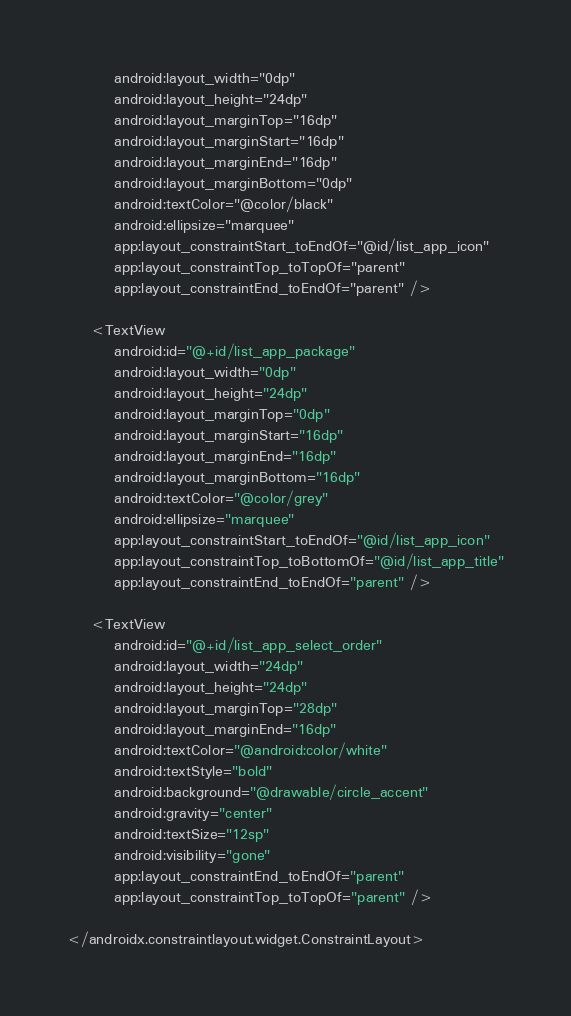Convert code to text. <code><loc_0><loc_0><loc_500><loc_500><_XML_>        android:layout_width="0dp"
        android:layout_height="24dp"
        android:layout_marginTop="16dp"
        android:layout_marginStart="16dp"
        android:layout_marginEnd="16dp"
        android:layout_marginBottom="0dp"
        android:textColor="@color/black"
        android:ellipsize="marquee"
        app:layout_constraintStart_toEndOf="@id/list_app_icon"
        app:layout_constraintTop_toTopOf="parent"
        app:layout_constraintEnd_toEndOf="parent" />

    <TextView
        android:id="@+id/list_app_package"
        android:layout_width="0dp"
        android:layout_height="24dp"
        android:layout_marginTop="0dp"
        android:layout_marginStart="16dp"
        android:layout_marginEnd="16dp"
        android:layout_marginBottom="16dp"
        android:textColor="@color/grey"
        android:ellipsize="marquee"
        app:layout_constraintStart_toEndOf="@id/list_app_icon"
        app:layout_constraintTop_toBottomOf="@id/list_app_title"
        app:layout_constraintEnd_toEndOf="parent" />

    <TextView
        android:id="@+id/list_app_select_order"
        android:layout_width="24dp"
        android:layout_height="24dp"
        android:layout_marginTop="28dp"
        android:layout_marginEnd="16dp"
        android:textColor="@android:color/white"
        android:textStyle="bold"
        android:background="@drawable/circle_accent"
        android:gravity="center"
        android:textSize="12sp"
        android:visibility="gone"
        app:layout_constraintEnd_toEndOf="parent"
        app:layout_constraintTop_toTopOf="parent" />

</androidx.constraintlayout.widget.ConstraintLayout></code> 